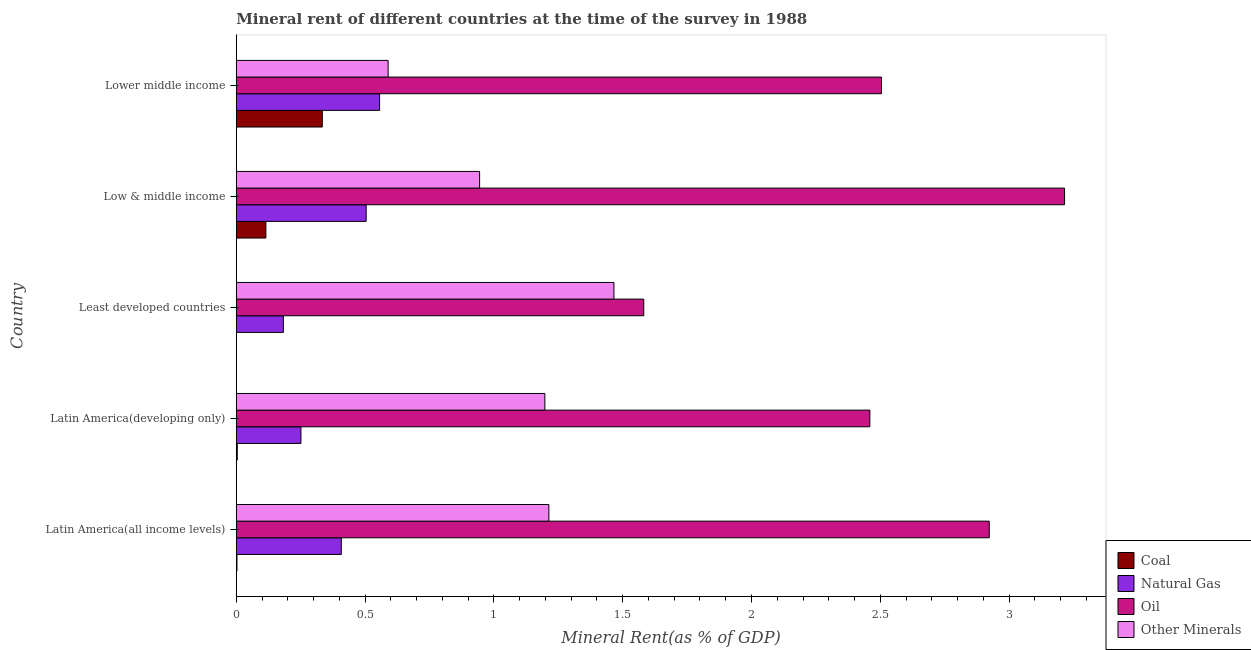How many different coloured bars are there?
Your response must be concise. 4. Are the number of bars per tick equal to the number of legend labels?
Keep it short and to the point. Yes. Are the number of bars on each tick of the Y-axis equal?
Make the answer very short. Yes. How many bars are there on the 5th tick from the bottom?
Give a very brief answer. 4. What is the label of the 3rd group of bars from the top?
Your response must be concise. Least developed countries. What is the  rent of other minerals in Low & middle income?
Offer a very short reply. 0.94. Across all countries, what is the maximum  rent of other minerals?
Provide a short and direct response. 1.47. Across all countries, what is the minimum  rent of other minerals?
Your response must be concise. 0.59. In which country was the natural gas rent maximum?
Provide a succinct answer. Lower middle income. In which country was the oil rent minimum?
Ensure brevity in your answer.  Least developed countries. What is the total oil rent in the graph?
Ensure brevity in your answer.  12.68. What is the difference between the natural gas rent in Low & middle income and that in Lower middle income?
Make the answer very short. -0.05. What is the difference between the coal rent in Low & middle income and the  rent of other minerals in Latin America(all income levels)?
Give a very brief answer. -1.1. What is the average natural gas rent per country?
Make the answer very short. 0.38. What is the difference between the coal rent and  rent of other minerals in Latin America(developing only)?
Your answer should be compact. -1.19. In how many countries, is the natural gas rent greater than 3.2 %?
Ensure brevity in your answer.  0. What is the ratio of the natural gas rent in Latin America(developing only) to that in Lower middle income?
Provide a succinct answer. 0.45. Is the oil rent in Low & middle income less than that in Lower middle income?
Your response must be concise. No. Is the difference between the  rent of other minerals in Latin America(all income levels) and Least developed countries greater than the difference between the coal rent in Latin America(all income levels) and Least developed countries?
Offer a terse response. No. What is the difference between the highest and the second highest  rent of other minerals?
Provide a short and direct response. 0.25. What is the difference between the highest and the lowest  rent of other minerals?
Provide a short and direct response. 0.88. In how many countries, is the natural gas rent greater than the average natural gas rent taken over all countries?
Your response must be concise. 3. Is it the case that in every country, the sum of the oil rent and natural gas rent is greater than the sum of  rent of other minerals and coal rent?
Keep it short and to the point. Yes. What does the 4th bar from the top in Latin America(developing only) represents?
Your answer should be compact. Coal. What does the 4th bar from the bottom in Lower middle income represents?
Give a very brief answer. Other Minerals. Is it the case that in every country, the sum of the coal rent and natural gas rent is greater than the oil rent?
Your answer should be very brief. No. Are all the bars in the graph horizontal?
Your answer should be very brief. Yes. What is the difference between two consecutive major ticks on the X-axis?
Offer a terse response. 0.5. Are the values on the major ticks of X-axis written in scientific E-notation?
Your response must be concise. No. Does the graph contain any zero values?
Provide a succinct answer. No. How are the legend labels stacked?
Keep it short and to the point. Vertical. What is the title of the graph?
Ensure brevity in your answer.  Mineral rent of different countries at the time of the survey in 1988. What is the label or title of the X-axis?
Provide a succinct answer. Mineral Rent(as % of GDP). What is the Mineral Rent(as % of GDP) of Coal in Latin America(all income levels)?
Provide a short and direct response. 0. What is the Mineral Rent(as % of GDP) in Natural Gas in Latin America(all income levels)?
Your answer should be very brief. 0.41. What is the Mineral Rent(as % of GDP) of Oil in Latin America(all income levels)?
Offer a very short reply. 2.92. What is the Mineral Rent(as % of GDP) in Other Minerals in Latin America(all income levels)?
Make the answer very short. 1.21. What is the Mineral Rent(as % of GDP) of Coal in Latin America(developing only)?
Provide a short and direct response. 0. What is the Mineral Rent(as % of GDP) of Natural Gas in Latin America(developing only)?
Your response must be concise. 0.25. What is the Mineral Rent(as % of GDP) in Oil in Latin America(developing only)?
Keep it short and to the point. 2.46. What is the Mineral Rent(as % of GDP) in Other Minerals in Latin America(developing only)?
Offer a terse response. 1.2. What is the Mineral Rent(as % of GDP) of Coal in Least developed countries?
Your answer should be very brief. 1.03994551316466e-5. What is the Mineral Rent(as % of GDP) of Natural Gas in Least developed countries?
Offer a very short reply. 0.18. What is the Mineral Rent(as % of GDP) of Oil in Least developed countries?
Your answer should be compact. 1.58. What is the Mineral Rent(as % of GDP) of Other Minerals in Least developed countries?
Your answer should be very brief. 1.47. What is the Mineral Rent(as % of GDP) in Coal in Low & middle income?
Provide a succinct answer. 0.11. What is the Mineral Rent(as % of GDP) of Natural Gas in Low & middle income?
Offer a very short reply. 0.5. What is the Mineral Rent(as % of GDP) of Oil in Low & middle income?
Provide a succinct answer. 3.22. What is the Mineral Rent(as % of GDP) of Other Minerals in Low & middle income?
Ensure brevity in your answer.  0.94. What is the Mineral Rent(as % of GDP) in Coal in Lower middle income?
Keep it short and to the point. 0.33. What is the Mineral Rent(as % of GDP) in Natural Gas in Lower middle income?
Provide a short and direct response. 0.56. What is the Mineral Rent(as % of GDP) in Oil in Lower middle income?
Your answer should be compact. 2.5. What is the Mineral Rent(as % of GDP) in Other Minerals in Lower middle income?
Keep it short and to the point. 0.59. Across all countries, what is the maximum Mineral Rent(as % of GDP) of Coal?
Offer a very short reply. 0.33. Across all countries, what is the maximum Mineral Rent(as % of GDP) in Natural Gas?
Your response must be concise. 0.56. Across all countries, what is the maximum Mineral Rent(as % of GDP) in Oil?
Ensure brevity in your answer.  3.22. Across all countries, what is the maximum Mineral Rent(as % of GDP) of Other Minerals?
Your response must be concise. 1.47. Across all countries, what is the minimum Mineral Rent(as % of GDP) of Coal?
Give a very brief answer. 1.03994551316466e-5. Across all countries, what is the minimum Mineral Rent(as % of GDP) in Natural Gas?
Provide a succinct answer. 0.18. Across all countries, what is the minimum Mineral Rent(as % of GDP) of Oil?
Give a very brief answer. 1.58. Across all countries, what is the minimum Mineral Rent(as % of GDP) in Other Minerals?
Offer a terse response. 0.59. What is the total Mineral Rent(as % of GDP) of Coal in the graph?
Provide a succinct answer. 0.46. What is the total Mineral Rent(as % of GDP) in Natural Gas in the graph?
Your response must be concise. 1.9. What is the total Mineral Rent(as % of GDP) in Oil in the graph?
Your response must be concise. 12.68. What is the total Mineral Rent(as % of GDP) in Other Minerals in the graph?
Ensure brevity in your answer.  5.41. What is the difference between the Mineral Rent(as % of GDP) in Coal in Latin America(all income levels) and that in Latin America(developing only)?
Your answer should be very brief. -0. What is the difference between the Mineral Rent(as % of GDP) of Natural Gas in Latin America(all income levels) and that in Latin America(developing only)?
Give a very brief answer. 0.16. What is the difference between the Mineral Rent(as % of GDP) of Oil in Latin America(all income levels) and that in Latin America(developing only)?
Offer a terse response. 0.46. What is the difference between the Mineral Rent(as % of GDP) in Other Minerals in Latin America(all income levels) and that in Latin America(developing only)?
Your answer should be very brief. 0.02. What is the difference between the Mineral Rent(as % of GDP) of Coal in Latin America(all income levels) and that in Least developed countries?
Your response must be concise. 0. What is the difference between the Mineral Rent(as % of GDP) in Natural Gas in Latin America(all income levels) and that in Least developed countries?
Ensure brevity in your answer.  0.22. What is the difference between the Mineral Rent(as % of GDP) in Oil in Latin America(all income levels) and that in Least developed countries?
Give a very brief answer. 1.34. What is the difference between the Mineral Rent(as % of GDP) of Other Minerals in Latin America(all income levels) and that in Least developed countries?
Your answer should be compact. -0.25. What is the difference between the Mineral Rent(as % of GDP) in Coal in Latin America(all income levels) and that in Low & middle income?
Keep it short and to the point. -0.11. What is the difference between the Mineral Rent(as % of GDP) of Natural Gas in Latin America(all income levels) and that in Low & middle income?
Keep it short and to the point. -0.1. What is the difference between the Mineral Rent(as % of GDP) of Oil in Latin America(all income levels) and that in Low & middle income?
Offer a very short reply. -0.29. What is the difference between the Mineral Rent(as % of GDP) in Other Minerals in Latin America(all income levels) and that in Low & middle income?
Provide a succinct answer. 0.27. What is the difference between the Mineral Rent(as % of GDP) of Coal in Latin America(all income levels) and that in Lower middle income?
Give a very brief answer. -0.33. What is the difference between the Mineral Rent(as % of GDP) in Natural Gas in Latin America(all income levels) and that in Lower middle income?
Give a very brief answer. -0.15. What is the difference between the Mineral Rent(as % of GDP) of Oil in Latin America(all income levels) and that in Lower middle income?
Your answer should be compact. 0.42. What is the difference between the Mineral Rent(as % of GDP) of Other Minerals in Latin America(all income levels) and that in Lower middle income?
Your answer should be very brief. 0.62. What is the difference between the Mineral Rent(as % of GDP) of Coal in Latin America(developing only) and that in Least developed countries?
Make the answer very short. 0. What is the difference between the Mineral Rent(as % of GDP) of Natural Gas in Latin America(developing only) and that in Least developed countries?
Offer a very short reply. 0.07. What is the difference between the Mineral Rent(as % of GDP) of Oil in Latin America(developing only) and that in Least developed countries?
Your answer should be compact. 0.88. What is the difference between the Mineral Rent(as % of GDP) of Other Minerals in Latin America(developing only) and that in Least developed countries?
Make the answer very short. -0.27. What is the difference between the Mineral Rent(as % of GDP) of Coal in Latin America(developing only) and that in Low & middle income?
Ensure brevity in your answer.  -0.11. What is the difference between the Mineral Rent(as % of GDP) of Natural Gas in Latin America(developing only) and that in Low & middle income?
Keep it short and to the point. -0.25. What is the difference between the Mineral Rent(as % of GDP) of Oil in Latin America(developing only) and that in Low & middle income?
Give a very brief answer. -0.76. What is the difference between the Mineral Rent(as % of GDP) in Other Minerals in Latin America(developing only) and that in Low & middle income?
Make the answer very short. 0.25. What is the difference between the Mineral Rent(as % of GDP) of Coal in Latin America(developing only) and that in Lower middle income?
Make the answer very short. -0.33. What is the difference between the Mineral Rent(as % of GDP) in Natural Gas in Latin America(developing only) and that in Lower middle income?
Your answer should be compact. -0.31. What is the difference between the Mineral Rent(as % of GDP) of Oil in Latin America(developing only) and that in Lower middle income?
Your answer should be compact. -0.05. What is the difference between the Mineral Rent(as % of GDP) of Other Minerals in Latin America(developing only) and that in Lower middle income?
Make the answer very short. 0.61. What is the difference between the Mineral Rent(as % of GDP) of Coal in Least developed countries and that in Low & middle income?
Offer a terse response. -0.11. What is the difference between the Mineral Rent(as % of GDP) in Natural Gas in Least developed countries and that in Low & middle income?
Give a very brief answer. -0.32. What is the difference between the Mineral Rent(as % of GDP) of Oil in Least developed countries and that in Low & middle income?
Make the answer very short. -1.63. What is the difference between the Mineral Rent(as % of GDP) of Other Minerals in Least developed countries and that in Low & middle income?
Provide a succinct answer. 0.52. What is the difference between the Mineral Rent(as % of GDP) of Coal in Least developed countries and that in Lower middle income?
Offer a very short reply. -0.33. What is the difference between the Mineral Rent(as % of GDP) of Natural Gas in Least developed countries and that in Lower middle income?
Provide a short and direct response. -0.37. What is the difference between the Mineral Rent(as % of GDP) of Oil in Least developed countries and that in Lower middle income?
Keep it short and to the point. -0.92. What is the difference between the Mineral Rent(as % of GDP) in Other Minerals in Least developed countries and that in Lower middle income?
Keep it short and to the point. 0.88. What is the difference between the Mineral Rent(as % of GDP) of Coal in Low & middle income and that in Lower middle income?
Keep it short and to the point. -0.22. What is the difference between the Mineral Rent(as % of GDP) in Natural Gas in Low & middle income and that in Lower middle income?
Offer a very short reply. -0.05. What is the difference between the Mineral Rent(as % of GDP) of Oil in Low & middle income and that in Lower middle income?
Keep it short and to the point. 0.71. What is the difference between the Mineral Rent(as % of GDP) of Other Minerals in Low & middle income and that in Lower middle income?
Offer a very short reply. 0.36. What is the difference between the Mineral Rent(as % of GDP) of Coal in Latin America(all income levels) and the Mineral Rent(as % of GDP) of Natural Gas in Latin America(developing only)?
Ensure brevity in your answer.  -0.25. What is the difference between the Mineral Rent(as % of GDP) of Coal in Latin America(all income levels) and the Mineral Rent(as % of GDP) of Oil in Latin America(developing only)?
Your answer should be compact. -2.46. What is the difference between the Mineral Rent(as % of GDP) in Coal in Latin America(all income levels) and the Mineral Rent(as % of GDP) in Other Minerals in Latin America(developing only)?
Offer a very short reply. -1.2. What is the difference between the Mineral Rent(as % of GDP) of Natural Gas in Latin America(all income levels) and the Mineral Rent(as % of GDP) of Oil in Latin America(developing only)?
Your response must be concise. -2.05. What is the difference between the Mineral Rent(as % of GDP) of Natural Gas in Latin America(all income levels) and the Mineral Rent(as % of GDP) of Other Minerals in Latin America(developing only)?
Your answer should be very brief. -0.79. What is the difference between the Mineral Rent(as % of GDP) in Oil in Latin America(all income levels) and the Mineral Rent(as % of GDP) in Other Minerals in Latin America(developing only)?
Keep it short and to the point. 1.73. What is the difference between the Mineral Rent(as % of GDP) of Coal in Latin America(all income levels) and the Mineral Rent(as % of GDP) of Natural Gas in Least developed countries?
Ensure brevity in your answer.  -0.18. What is the difference between the Mineral Rent(as % of GDP) of Coal in Latin America(all income levels) and the Mineral Rent(as % of GDP) of Oil in Least developed countries?
Provide a short and direct response. -1.58. What is the difference between the Mineral Rent(as % of GDP) in Coal in Latin America(all income levels) and the Mineral Rent(as % of GDP) in Other Minerals in Least developed countries?
Keep it short and to the point. -1.46. What is the difference between the Mineral Rent(as % of GDP) of Natural Gas in Latin America(all income levels) and the Mineral Rent(as % of GDP) of Oil in Least developed countries?
Make the answer very short. -1.17. What is the difference between the Mineral Rent(as % of GDP) of Natural Gas in Latin America(all income levels) and the Mineral Rent(as % of GDP) of Other Minerals in Least developed countries?
Offer a very short reply. -1.06. What is the difference between the Mineral Rent(as % of GDP) in Oil in Latin America(all income levels) and the Mineral Rent(as % of GDP) in Other Minerals in Least developed countries?
Your answer should be very brief. 1.46. What is the difference between the Mineral Rent(as % of GDP) in Coal in Latin America(all income levels) and the Mineral Rent(as % of GDP) in Natural Gas in Low & middle income?
Keep it short and to the point. -0.5. What is the difference between the Mineral Rent(as % of GDP) in Coal in Latin America(all income levels) and the Mineral Rent(as % of GDP) in Oil in Low & middle income?
Offer a terse response. -3.21. What is the difference between the Mineral Rent(as % of GDP) of Coal in Latin America(all income levels) and the Mineral Rent(as % of GDP) of Other Minerals in Low & middle income?
Make the answer very short. -0.94. What is the difference between the Mineral Rent(as % of GDP) in Natural Gas in Latin America(all income levels) and the Mineral Rent(as % of GDP) in Oil in Low & middle income?
Your answer should be compact. -2.81. What is the difference between the Mineral Rent(as % of GDP) of Natural Gas in Latin America(all income levels) and the Mineral Rent(as % of GDP) of Other Minerals in Low & middle income?
Offer a very short reply. -0.54. What is the difference between the Mineral Rent(as % of GDP) in Oil in Latin America(all income levels) and the Mineral Rent(as % of GDP) in Other Minerals in Low & middle income?
Provide a short and direct response. 1.98. What is the difference between the Mineral Rent(as % of GDP) of Coal in Latin America(all income levels) and the Mineral Rent(as % of GDP) of Natural Gas in Lower middle income?
Your answer should be very brief. -0.55. What is the difference between the Mineral Rent(as % of GDP) in Coal in Latin America(all income levels) and the Mineral Rent(as % of GDP) in Oil in Lower middle income?
Give a very brief answer. -2.5. What is the difference between the Mineral Rent(as % of GDP) of Coal in Latin America(all income levels) and the Mineral Rent(as % of GDP) of Other Minerals in Lower middle income?
Ensure brevity in your answer.  -0.59. What is the difference between the Mineral Rent(as % of GDP) of Natural Gas in Latin America(all income levels) and the Mineral Rent(as % of GDP) of Oil in Lower middle income?
Make the answer very short. -2.1. What is the difference between the Mineral Rent(as % of GDP) in Natural Gas in Latin America(all income levels) and the Mineral Rent(as % of GDP) in Other Minerals in Lower middle income?
Your answer should be compact. -0.18. What is the difference between the Mineral Rent(as % of GDP) of Oil in Latin America(all income levels) and the Mineral Rent(as % of GDP) of Other Minerals in Lower middle income?
Provide a short and direct response. 2.33. What is the difference between the Mineral Rent(as % of GDP) in Coal in Latin America(developing only) and the Mineral Rent(as % of GDP) in Natural Gas in Least developed countries?
Provide a short and direct response. -0.18. What is the difference between the Mineral Rent(as % of GDP) in Coal in Latin America(developing only) and the Mineral Rent(as % of GDP) in Oil in Least developed countries?
Your answer should be compact. -1.58. What is the difference between the Mineral Rent(as % of GDP) in Coal in Latin America(developing only) and the Mineral Rent(as % of GDP) in Other Minerals in Least developed countries?
Ensure brevity in your answer.  -1.46. What is the difference between the Mineral Rent(as % of GDP) of Natural Gas in Latin America(developing only) and the Mineral Rent(as % of GDP) of Oil in Least developed countries?
Your answer should be very brief. -1.33. What is the difference between the Mineral Rent(as % of GDP) of Natural Gas in Latin America(developing only) and the Mineral Rent(as % of GDP) of Other Minerals in Least developed countries?
Make the answer very short. -1.22. What is the difference between the Mineral Rent(as % of GDP) in Coal in Latin America(developing only) and the Mineral Rent(as % of GDP) in Natural Gas in Low & middle income?
Make the answer very short. -0.5. What is the difference between the Mineral Rent(as % of GDP) of Coal in Latin America(developing only) and the Mineral Rent(as % of GDP) of Oil in Low & middle income?
Keep it short and to the point. -3.21. What is the difference between the Mineral Rent(as % of GDP) of Coal in Latin America(developing only) and the Mineral Rent(as % of GDP) of Other Minerals in Low & middle income?
Your answer should be very brief. -0.94. What is the difference between the Mineral Rent(as % of GDP) of Natural Gas in Latin America(developing only) and the Mineral Rent(as % of GDP) of Oil in Low & middle income?
Your answer should be very brief. -2.96. What is the difference between the Mineral Rent(as % of GDP) of Natural Gas in Latin America(developing only) and the Mineral Rent(as % of GDP) of Other Minerals in Low & middle income?
Your answer should be compact. -0.69. What is the difference between the Mineral Rent(as % of GDP) in Oil in Latin America(developing only) and the Mineral Rent(as % of GDP) in Other Minerals in Low & middle income?
Your answer should be compact. 1.51. What is the difference between the Mineral Rent(as % of GDP) of Coal in Latin America(developing only) and the Mineral Rent(as % of GDP) of Natural Gas in Lower middle income?
Keep it short and to the point. -0.55. What is the difference between the Mineral Rent(as % of GDP) of Coal in Latin America(developing only) and the Mineral Rent(as % of GDP) of Oil in Lower middle income?
Offer a very short reply. -2.5. What is the difference between the Mineral Rent(as % of GDP) in Coal in Latin America(developing only) and the Mineral Rent(as % of GDP) in Other Minerals in Lower middle income?
Keep it short and to the point. -0.59. What is the difference between the Mineral Rent(as % of GDP) of Natural Gas in Latin America(developing only) and the Mineral Rent(as % of GDP) of Oil in Lower middle income?
Your answer should be very brief. -2.25. What is the difference between the Mineral Rent(as % of GDP) of Natural Gas in Latin America(developing only) and the Mineral Rent(as % of GDP) of Other Minerals in Lower middle income?
Your response must be concise. -0.34. What is the difference between the Mineral Rent(as % of GDP) in Oil in Latin America(developing only) and the Mineral Rent(as % of GDP) in Other Minerals in Lower middle income?
Make the answer very short. 1.87. What is the difference between the Mineral Rent(as % of GDP) in Coal in Least developed countries and the Mineral Rent(as % of GDP) in Natural Gas in Low & middle income?
Your answer should be compact. -0.5. What is the difference between the Mineral Rent(as % of GDP) in Coal in Least developed countries and the Mineral Rent(as % of GDP) in Oil in Low & middle income?
Ensure brevity in your answer.  -3.22. What is the difference between the Mineral Rent(as % of GDP) in Coal in Least developed countries and the Mineral Rent(as % of GDP) in Other Minerals in Low & middle income?
Keep it short and to the point. -0.94. What is the difference between the Mineral Rent(as % of GDP) of Natural Gas in Least developed countries and the Mineral Rent(as % of GDP) of Oil in Low & middle income?
Provide a succinct answer. -3.03. What is the difference between the Mineral Rent(as % of GDP) in Natural Gas in Least developed countries and the Mineral Rent(as % of GDP) in Other Minerals in Low & middle income?
Keep it short and to the point. -0.76. What is the difference between the Mineral Rent(as % of GDP) in Oil in Least developed countries and the Mineral Rent(as % of GDP) in Other Minerals in Low & middle income?
Give a very brief answer. 0.64. What is the difference between the Mineral Rent(as % of GDP) in Coal in Least developed countries and the Mineral Rent(as % of GDP) in Natural Gas in Lower middle income?
Provide a succinct answer. -0.56. What is the difference between the Mineral Rent(as % of GDP) of Coal in Least developed countries and the Mineral Rent(as % of GDP) of Oil in Lower middle income?
Keep it short and to the point. -2.5. What is the difference between the Mineral Rent(as % of GDP) in Coal in Least developed countries and the Mineral Rent(as % of GDP) in Other Minerals in Lower middle income?
Make the answer very short. -0.59. What is the difference between the Mineral Rent(as % of GDP) in Natural Gas in Least developed countries and the Mineral Rent(as % of GDP) in Oil in Lower middle income?
Your response must be concise. -2.32. What is the difference between the Mineral Rent(as % of GDP) in Natural Gas in Least developed countries and the Mineral Rent(as % of GDP) in Other Minerals in Lower middle income?
Give a very brief answer. -0.41. What is the difference between the Mineral Rent(as % of GDP) in Coal in Low & middle income and the Mineral Rent(as % of GDP) in Natural Gas in Lower middle income?
Provide a short and direct response. -0.44. What is the difference between the Mineral Rent(as % of GDP) of Coal in Low & middle income and the Mineral Rent(as % of GDP) of Oil in Lower middle income?
Give a very brief answer. -2.39. What is the difference between the Mineral Rent(as % of GDP) in Coal in Low & middle income and the Mineral Rent(as % of GDP) in Other Minerals in Lower middle income?
Make the answer very short. -0.47. What is the difference between the Mineral Rent(as % of GDP) of Natural Gas in Low & middle income and the Mineral Rent(as % of GDP) of Oil in Lower middle income?
Your answer should be very brief. -2. What is the difference between the Mineral Rent(as % of GDP) of Natural Gas in Low & middle income and the Mineral Rent(as % of GDP) of Other Minerals in Lower middle income?
Offer a terse response. -0.09. What is the difference between the Mineral Rent(as % of GDP) of Oil in Low & middle income and the Mineral Rent(as % of GDP) of Other Minerals in Lower middle income?
Ensure brevity in your answer.  2.63. What is the average Mineral Rent(as % of GDP) in Coal per country?
Offer a very short reply. 0.09. What is the average Mineral Rent(as % of GDP) of Natural Gas per country?
Make the answer very short. 0.38. What is the average Mineral Rent(as % of GDP) in Oil per country?
Give a very brief answer. 2.54. What is the average Mineral Rent(as % of GDP) of Other Minerals per country?
Provide a succinct answer. 1.08. What is the difference between the Mineral Rent(as % of GDP) in Coal and Mineral Rent(as % of GDP) in Natural Gas in Latin America(all income levels)?
Offer a very short reply. -0.41. What is the difference between the Mineral Rent(as % of GDP) in Coal and Mineral Rent(as % of GDP) in Oil in Latin America(all income levels)?
Provide a short and direct response. -2.92. What is the difference between the Mineral Rent(as % of GDP) of Coal and Mineral Rent(as % of GDP) of Other Minerals in Latin America(all income levels)?
Provide a succinct answer. -1.21. What is the difference between the Mineral Rent(as % of GDP) in Natural Gas and Mineral Rent(as % of GDP) in Oil in Latin America(all income levels)?
Provide a succinct answer. -2.52. What is the difference between the Mineral Rent(as % of GDP) in Natural Gas and Mineral Rent(as % of GDP) in Other Minerals in Latin America(all income levels)?
Give a very brief answer. -0.81. What is the difference between the Mineral Rent(as % of GDP) in Oil and Mineral Rent(as % of GDP) in Other Minerals in Latin America(all income levels)?
Your response must be concise. 1.71. What is the difference between the Mineral Rent(as % of GDP) in Coal and Mineral Rent(as % of GDP) in Natural Gas in Latin America(developing only)?
Your answer should be compact. -0.25. What is the difference between the Mineral Rent(as % of GDP) in Coal and Mineral Rent(as % of GDP) in Oil in Latin America(developing only)?
Offer a terse response. -2.46. What is the difference between the Mineral Rent(as % of GDP) of Coal and Mineral Rent(as % of GDP) of Other Minerals in Latin America(developing only)?
Offer a very short reply. -1.19. What is the difference between the Mineral Rent(as % of GDP) of Natural Gas and Mineral Rent(as % of GDP) of Oil in Latin America(developing only)?
Give a very brief answer. -2.21. What is the difference between the Mineral Rent(as % of GDP) of Natural Gas and Mineral Rent(as % of GDP) of Other Minerals in Latin America(developing only)?
Your answer should be compact. -0.95. What is the difference between the Mineral Rent(as % of GDP) in Oil and Mineral Rent(as % of GDP) in Other Minerals in Latin America(developing only)?
Ensure brevity in your answer.  1.26. What is the difference between the Mineral Rent(as % of GDP) in Coal and Mineral Rent(as % of GDP) in Natural Gas in Least developed countries?
Provide a short and direct response. -0.18. What is the difference between the Mineral Rent(as % of GDP) in Coal and Mineral Rent(as % of GDP) in Oil in Least developed countries?
Your response must be concise. -1.58. What is the difference between the Mineral Rent(as % of GDP) of Coal and Mineral Rent(as % of GDP) of Other Minerals in Least developed countries?
Make the answer very short. -1.47. What is the difference between the Mineral Rent(as % of GDP) of Natural Gas and Mineral Rent(as % of GDP) of Oil in Least developed countries?
Keep it short and to the point. -1.4. What is the difference between the Mineral Rent(as % of GDP) in Natural Gas and Mineral Rent(as % of GDP) in Other Minerals in Least developed countries?
Give a very brief answer. -1.28. What is the difference between the Mineral Rent(as % of GDP) of Oil and Mineral Rent(as % of GDP) of Other Minerals in Least developed countries?
Your answer should be very brief. 0.12. What is the difference between the Mineral Rent(as % of GDP) in Coal and Mineral Rent(as % of GDP) in Natural Gas in Low & middle income?
Provide a short and direct response. -0.39. What is the difference between the Mineral Rent(as % of GDP) in Coal and Mineral Rent(as % of GDP) in Oil in Low & middle income?
Provide a short and direct response. -3.1. What is the difference between the Mineral Rent(as % of GDP) in Coal and Mineral Rent(as % of GDP) in Other Minerals in Low & middle income?
Keep it short and to the point. -0.83. What is the difference between the Mineral Rent(as % of GDP) in Natural Gas and Mineral Rent(as % of GDP) in Oil in Low & middle income?
Your answer should be very brief. -2.71. What is the difference between the Mineral Rent(as % of GDP) in Natural Gas and Mineral Rent(as % of GDP) in Other Minerals in Low & middle income?
Give a very brief answer. -0.44. What is the difference between the Mineral Rent(as % of GDP) of Oil and Mineral Rent(as % of GDP) of Other Minerals in Low & middle income?
Provide a succinct answer. 2.27. What is the difference between the Mineral Rent(as % of GDP) of Coal and Mineral Rent(as % of GDP) of Natural Gas in Lower middle income?
Your answer should be compact. -0.22. What is the difference between the Mineral Rent(as % of GDP) in Coal and Mineral Rent(as % of GDP) in Oil in Lower middle income?
Your answer should be very brief. -2.17. What is the difference between the Mineral Rent(as % of GDP) of Coal and Mineral Rent(as % of GDP) of Other Minerals in Lower middle income?
Your response must be concise. -0.26. What is the difference between the Mineral Rent(as % of GDP) in Natural Gas and Mineral Rent(as % of GDP) in Oil in Lower middle income?
Make the answer very short. -1.95. What is the difference between the Mineral Rent(as % of GDP) in Natural Gas and Mineral Rent(as % of GDP) in Other Minerals in Lower middle income?
Your response must be concise. -0.03. What is the difference between the Mineral Rent(as % of GDP) in Oil and Mineral Rent(as % of GDP) in Other Minerals in Lower middle income?
Keep it short and to the point. 1.92. What is the ratio of the Mineral Rent(as % of GDP) in Coal in Latin America(all income levels) to that in Latin America(developing only)?
Provide a succinct answer. 0.72. What is the ratio of the Mineral Rent(as % of GDP) of Natural Gas in Latin America(all income levels) to that in Latin America(developing only)?
Ensure brevity in your answer.  1.62. What is the ratio of the Mineral Rent(as % of GDP) in Oil in Latin America(all income levels) to that in Latin America(developing only)?
Give a very brief answer. 1.19. What is the ratio of the Mineral Rent(as % of GDP) in Coal in Latin America(all income levels) to that in Least developed countries?
Your answer should be very brief. 274.04. What is the ratio of the Mineral Rent(as % of GDP) in Natural Gas in Latin America(all income levels) to that in Least developed countries?
Offer a terse response. 2.23. What is the ratio of the Mineral Rent(as % of GDP) of Oil in Latin America(all income levels) to that in Least developed countries?
Offer a very short reply. 1.85. What is the ratio of the Mineral Rent(as % of GDP) in Other Minerals in Latin America(all income levels) to that in Least developed countries?
Provide a short and direct response. 0.83. What is the ratio of the Mineral Rent(as % of GDP) of Coal in Latin America(all income levels) to that in Low & middle income?
Provide a succinct answer. 0.02. What is the ratio of the Mineral Rent(as % of GDP) of Natural Gas in Latin America(all income levels) to that in Low & middle income?
Give a very brief answer. 0.81. What is the ratio of the Mineral Rent(as % of GDP) of Oil in Latin America(all income levels) to that in Low & middle income?
Give a very brief answer. 0.91. What is the ratio of the Mineral Rent(as % of GDP) of Other Minerals in Latin America(all income levels) to that in Low & middle income?
Offer a very short reply. 1.28. What is the ratio of the Mineral Rent(as % of GDP) in Coal in Latin America(all income levels) to that in Lower middle income?
Offer a terse response. 0.01. What is the ratio of the Mineral Rent(as % of GDP) in Natural Gas in Latin America(all income levels) to that in Lower middle income?
Make the answer very short. 0.73. What is the ratio of the Mineral Rent(as % of GDP) of Oil in Latin America(all income levels) to that in Lower middle income?
Provide a short and direct response. 1.17. What is the ratio of the Mineral Rent(as % of GDP) in Other Minerals in Latin America(all income levels) to that in Lower middle income?
Make the answer very short. 2.06. What is the ratio of the Mineral Rent(as % of GDP) of Coal in Latin America(developing only) to that in Least developed countries?
Make the answer very short. 379.96. What is the ratio of the Mineral Rent(as % of GDP) in Natural Gas in Latin America(developing only) to that in Least developed countries?
Your answer should be very brief. 1.37. What is the ratio of the Mineral Rent(as % of GDP) in Oil in Latin America(developing only) to that in Least developed countries?
Your answer should be very brief. 1.55. What is the ratio of the Mineral Rent(as % of GDP) in Other Minerals in Latin America(developing only) to that in Least developed countries?
Ensure brevity in your answer.  0.82. What is the ratio of the Mineral Rent(as % of GDP) of Coal in Latin America(developing only) to that in Low & middle income?
Your response must be concise. 0.03. What is the ratio of the Mineral Rent(as % of GDP) of Natural Gas in Latin America(developing only) to that in Low & middle income?
Give a very brief answer. 0.5. What is the ratio of the Mineral Rent(as % of GDP) in Oil in Latin America(developing only) to that in Low & middle income?
Your answer should be compact. 0.76. What is the ratio of the Mineral Rent(as % of GDP) in Other Minerals in Latin America(developing only) to that in Low & middle income?
Your answer should be compact. 1.27. What is the ratio of the Mineral Rent(as % of GDP) of Coal in Latin America(developing only) to that in Lower middle income?
Keep it short and to the point. 0.01. What is the ratio of the Mineral Rent(as % of GDP) of Natural Gas in Latin America(developing only) to that in Lower middle income?
Offer a very short reply. 0.45. What is the ratio of the Mineral Rent(as % of GDP) in Oil in Latin America(developing only) to that in Lower middle income?
Your answer should be compact. 0.98. What is the ratio of the Mineral Rent(as % of GDP) of Other Minerals in Latin America(developing only) to that in Lower middle income?
Your answer should be very brief. 2.03. What is the ratio of the Mineral Rent(as % of GDP) in Natural Gas in Least developed countries to that in Low & middle income?
Provide a short and direct response. 0.36. What is the ratio of the Mineral Rent(as % of GDP) of Oil in Least developed countries to that in Low & middle income?
Your response must be concise. 0.49. What is the ratio of the Mineral Rent(as % of GDP) of Other Minerals in Least developed countries to that in Low & middle income?
Your response must be concise. 1.55. What is the ratio of the Mineral Rent(as % of GDP) in Coal in Least developed countries to that in Lower middle income?
Your answer should be compact. 0. What is the ratio of the Mineral Rent(as % of GDP) of Natural Gas in Least developed countries to that in Lower middle income?
Ensure brevity in your answer.  0.33. What is the ratio of the Mineral Rent(as % of GDP) of Oil in Least developed countries to that in Lower middle income?
Your answer should be very brief. 0.63. What is the ratio of the Mineral Rent(as % of GDP) in Other Minerals in Least developed countries to that in Lower middle income?
Keep it short and to the point. 2.49. What is the ratio of the Mineral Rent(as % of GDP) of Coal in Low & middle income to that in Lower middle income?
Keep it short and to the point. 0.34. What is the ratio of the Mineral Rent(as % of GDP) in Natural Gas in Low & middle income to that in Lower middle income?
Your answer should be very brief. 0.91. What is the ratio of the Mineral Rent(as % of GDP) of Oil in Low & middle income to that in Lower middle income?
Your answer should be very brief. 1.28. What is the ratio of the Mineral Rent(as % of GDP) in Other Minerals in Low & middle income to that in Lower middle income?
Your answer should be compact. 1.6. What is the difference between the highest and the second highest Mineral Rent(as % of GDP) in Coal?
Give a very brief answer. 0.22. What is the difference between the highest and the second highest Mineral Rent(as % of GDP) in Natural Gas?
Your answer should be compact. 0.05. What is the difference between the highest and the second highest Mineral Rent(as % of GDP) in Oil?
Your answer should be compact. 0.29. What is the difference between the highest and the second highest Mineral Rent(as % of GDP) in Other Minerals?
Offer a terse response. 0.25. What is the difference between the highest and the lowest Mineral Rent(as % of GDP) of Coal?
Give a very brief answer. 0.33. What is the difference between the highest and the lowest Mineral Rent(as % of GDP) in Natural Gas?
Your answer should be very brief. 0.37. What is the difference between the highest and the lowest Mineral Rent(as % of GDP) in Oil?
Your answer should be very brief. 1.63. What is the difference between the highest and the lowest Mineral Rent(as % of GDP) of Other Minerals?
Your answer should be very brief. 0.88. 